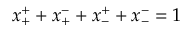Convert formula to latex. <formula><loc_0><loc_0><loc_500><loc_500>x _ { + } ^ { + } + x _ { + } ^ { - } + x _ { - } ^ { + } + x _ { - } ^ { - } = 1</formula> 